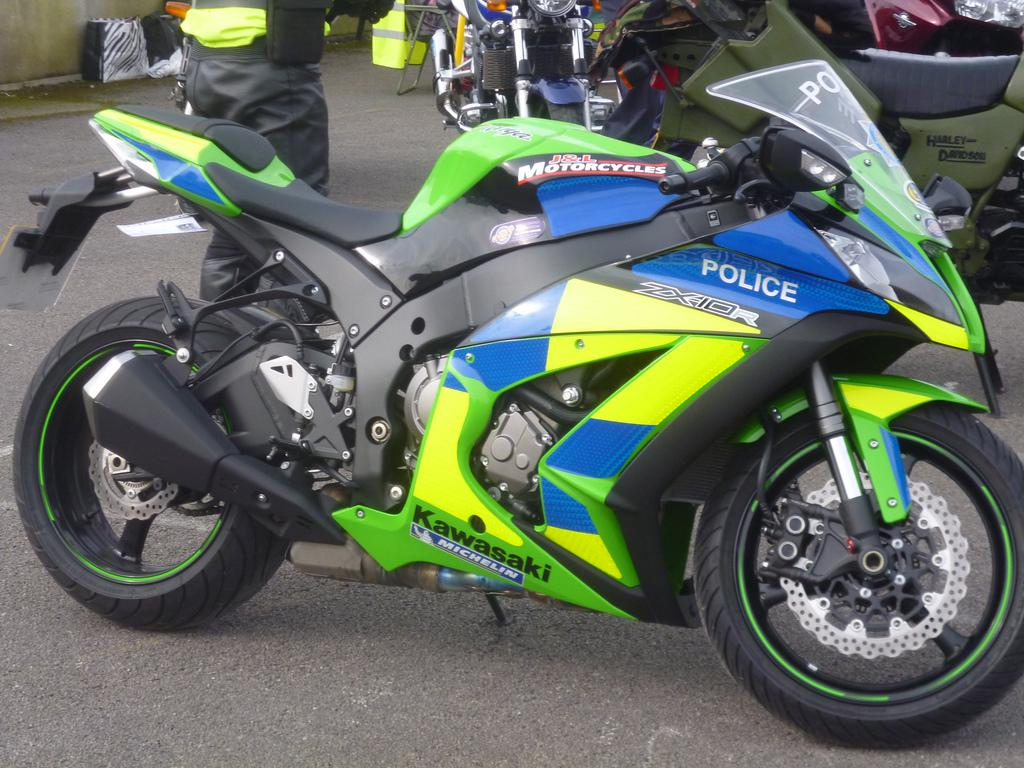Question: how many tires are visible?
Choices:
A. Three.
B. 4.
C. Two.
D. 1.
Answer with the letter. Answer: C Question: how does the container appear?
Choices:
A. Leopard-print.
B. Tiger-striped.
C. Snakeskin-print.
D. Zebra-striped.
Answer with the letter. Answer: D Question: what make is the motorcycle?
Choices:
A. Harley Davidson.
B. Suzuki.
C. Yamaha.
D. Kawasaki.
Answer with the letter. Answer: D Question: how tires are there?
Choices:
A. One.
B. Eight.
C. Two.
D. Four.
Answer with the letter. Answer: C Question: who uses this motorcycle?
Choices:
A. Police.
B. A biker.
C. A daredevil.
D. A young man.
Answer with the letter. Answer: A Question: who stands near a motorcycle?
Choices:
A. A woman.
B. A child.
C. A man.
D. A baker delivering cookies.
Answer with the letter. Answer: C Question: what is the motorcycle leaning on?
Choices:
A. The building.
B. Its kickstand.
C. The wall.
D. The bike rack.
Answer with the letter. Answer: B Question: what is sitting near a wall?
Choices:
A. The chair.
B. The flower pot.
C. The scooter.
D. Some bags.
Answer with the letter. Answer: D Question: what color is the shirt?
Choices:
A. Blue.
B. Yellow.
C. Orange.
D. Green.
Answer with the letter. Answer: B Question: what is parked?
Choices:
A. Cars.
B. The bus.
C. The scooter.
D. Motorcycles.
Answer with the letter. Answer: D Question: who does this motorcycle belong to?
Choices:
A. The club.
B. The police.
C. The man.
D. The woman.
Answer with the letter. Answer: B 